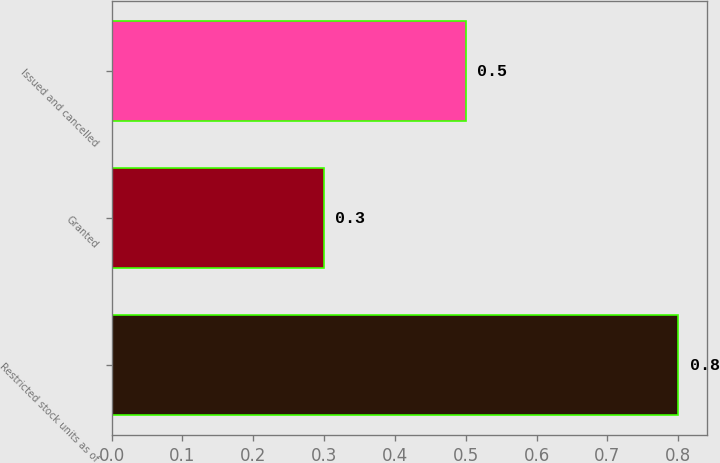Convert chart. <chart><loc_0><loc_0><loc_500><loc_500><bar_chart><fcel>Restricted stock units as of<fcel>Granted<fcel>Issued and cancelled<nl><fcel>0.8<fcel>0.3<fcel>0.5<nl></chart> 